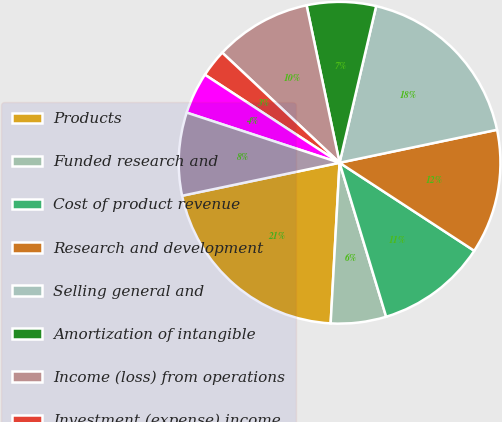Convert chart to OTSL. <chart><loc_0><loc_0><loc_500><loc_500><pie_chart><fcel>Products<fcel>Funded research and<fcel>Cost of product revenue<fcel>Research and development<fcel>Selling general and<fcel>Amortization of intangible<fcel>Income (loss) from operations<fcel>Investment (expense) income<fcel>Other income (expense) net<fcel>Income (loss) before income<nl><fcel>20.83%<fcel>5.56%<fcel>11.11%<fcel>12.5%<fcel>18.06%<fcel>6.94%<fcel>9.72%<fcel>2.78%<fcel>4.17%<fcel>8.33%<nl></chart> 